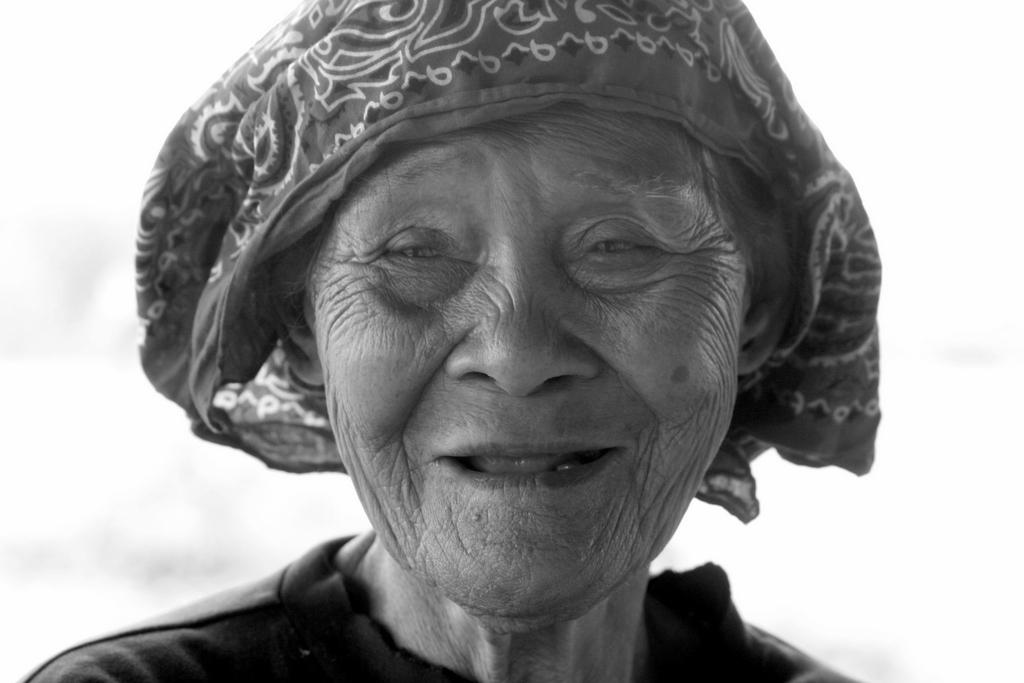Who is the main subject in the image? There is an old lady in the image. What is the old lady doing in the image? The old lady is smiling. How many tickets does the old lady have in the image? There are no tickets present in the image. 